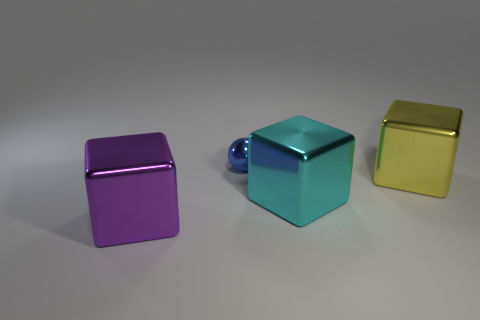Add 4 large cyan cubes. How many objects exist? 8 Subtract all balls. How many objects are left? 3 Add 3 yellow things. How many yellow things exist? 4 Subtract 0 brown cylinders. How many objects are left? 4 Subtract all tiny purple metallic things. Subtract all cubes. How many objects are left? 1 Add 3 small blue balls. How many small blue balls are left? 4 